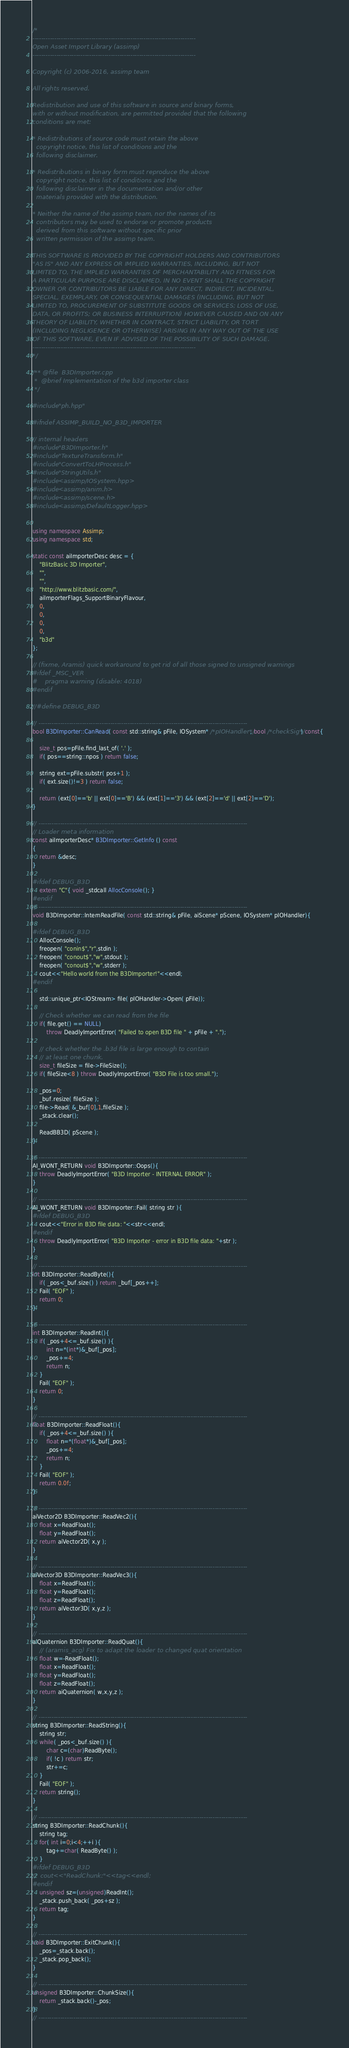Convert code to text. <code><loc_0><loc_0><loc_500><loc_500><_C++_>/*
---------------------------------------------------------------------------
Open Asset Import Library (assimp)
---------------------------------------------------------------------------

Copyright (c) 2006-2016, assimp team

All rights reserved.

Redistribution and use of this software in source and binary forms,
with or without modification, are permitted provided that the following
conditions are met:

* Redistributions of source code must retain the above
  copyright notice, this list of conditions and the
  following disclaimer.

* Redistributions in binary form must reproduce the above
  copyright notice, this list of conditions and the
  following disclaimer in the documentation and/or other
  materials provided with the distribution.

* Neither the name of the assimp team, nor the names of its
  contributors may be used to endorse or promote products
  derived from this software without specific prior
  written permission of the assimp team.

THIS SOFTWARE IS PROVIDED BY THE COPYRIGHT HOLDERS AND CONTRIBUTORS
"AS IS" AND ANY EXPRESS OR IMPLIED WARRANTIES, INCLUDING, BUT NOT
LIMITED TO, THE IMPLIED WARRANTIES OF MERCHANTABILITY AND FITNESS FOR
A PARTICULAR PURPOSE ARE DISCLAIMED. IN NO EVENT SHALL THE COPYRIGHT
OWNER OR CONTRIBUTORS BE LIABLE FOR ANY DIRECT, INDIRECT, INCIDENTAL,
SPECIAL, EXEMPLARY, OR CONSEQUENTIAL DAMAGES (INCLUDING, BUT NOT
LIMITED TO, PROCUREMENT OF SUBSTITUTE GOODS OR SERVICES; LOSS OF USE,
DATA, OR PROFITS; OR BUSINESS INTERRUPTION) HOWEVER CAUSED AND ON ANY
THEORY OF LIABILITY, WHETHER IN CONTRACT, STRICT LIABILITY, OR TORT
(INCLUDING NEGLIGENCE OR OTHERWISE) ARISING IN ANY WAY OUT OF THE USE
OF THIS SOFTWARE, EVEN IF ADVISED OF THE POSSIBILITY OF SUCH DAMAGE.
---------------------------------------------------------------------------
*/

/** @file  B3DImporter.cpp
 *  @brief Implementation of the b3d importer class
 */

#include "ph.hpp"

#ifndef ASSIMP_BUILD_NO_B3D_IMPORTER

// internal headers
#include "B3DImporter.h"
#include "TextureTransform.h"
#include "ConvertToLHProcess.h"
#include "StringUtils.h"
#include <assimp/IOSystem.hpp>
#include <assimp/anim.h>
#include <assimp/scene.h>
#include <assimp/DefaultLogger.hpp>


using namespace Assimp;
using namespace std;

static const aiImporterDesc desc = {
    "BlitzBasic 3D Importer",
    "",
    "",
    "http://www.blitzbasic.com/",
    aiImporterFlags_SupportBinaryFlavour,
    0,
    0,
    0,
    0,
    "b3d"
};

// (fixme, Aramis) quick workaround to get rid of all those signed to unsigned warnings
#ifdef _MSC_VER
#	pragma warning (disable: 4018)
#endif

//#define DEBUG_B3D

// ------------------------------------------------------------------------------------------------
bool B3DImporter::CanRead( const std::string& pFile, IOSystem* /*pIOHandler*/, bool /*checkSig*/) const{

    size_t pos=pFile.find_last_of( '.' );
    if( pos==string::npos ) return false;

    string ext=pFile.substr( pos+1 );
    if( ext.size()!=3 ) return false;

    return (ext[0]=='b' || ext[0]=='B') && (ext[1]=='3') && (ext[2]=='d' || ext[2]=='D');
}

// ------------------------------------------------------------------------------------------------
// Loader meta information
const aiImporterDesc* B3DImporter::GetInfo () const
{
    return &desc;
}

#ifdef DEBUG_B3D
    extern "C"{ void _stdcall AllocConsole(); }
#endif
// ------------------------------------------------------------------------------------------------
void B3DImporter::InternReadFile( const std::string& pFile, aiScene* pScene, IOSystem* pIOHandler){

#ifdef DEBUG_B3D
    AllocConsole();
    freopen( "conin$","r",stdin );
    freopen( "conout$","w",stdout );
    freopen( "conout$","w",stderr );
    cout<<"Hello world from the B3DImporter!"<<endl;
#endif

    std::unique_ptr<IOStream> file( pIOHandler->Open( pFile));

    // Check whether we can read from the file
    if( file.get() == NULL)
        throw DeadlyImportError( "Failed to open B3D file " + pFile + ".");

    // check whether the .b3d file is large enough to contain
    // at least one chunk.
    size_t fileSize = file->FileSize();
    if( fileSize<8 ) throw DeadlyImportError( "B3D File is too small.");

    _pos=0;
    _buf.resize( fileSize );
    file->Read( &_buf[0],1,fileSize );
    _stack.clear();

    ReadBB3D( pScene );
}

// ------------------------------------------------------------------------------------------------
AI_WONT_RETURN void B3DImporter::Oops(){
    throw DeadlyImportError( "B3D Importer - INTERNAL ERROR" );
}

// ------------------------------------------------------------------------------------------------
AI_WONT_RETURN void B3DImporter::Fail( string str ){
#ifdef DEBUG_B3D
    cout<<"Error in B3D file data: "<<str<<endl;
#endif
    throw DeadlyImportError( "B3D Importer - error in B3D file data: "+str );
}

// ------------------------------------------------------------------------------------------------
int B3DImporter::ReadByte(){
    if( _pos<_buf.size() ) return _buf[_pos++];
    Fail( "EOF" );
    return 0;
}

// ------------------------------------------------------------------------------------------------
int B3DImporter::ReadInt(){
    if( _pos+4<=_buf.size() ){
        int n=*(int*)&_buf[_pos];
        _pos+=4;
        return n;
    }
    Fail( "EOF" );
    return 0;
}

// ------------------------------------------------------------------------------------------------
float B3DImporter::ReadFloat(){
    if( _pos+4<=_buf.size() ){
        float n=*(float*)&_buf[_pos];
        _pos+=4;
        return n;
    }
    Fail( "EOF" );
    return 0.0f;
}

// ------------------------------------------------------------------------------------------------
aiVector2D B3DImporter::ReadVec2(){
    float x=ReadFloat();
    float y=ReadFloat();
    return aiVector2D( x,y );
}

// ------------------------------------------------------------------------------------------------
aiVector3D B3DImporter::ReadVec3(){
    float x=ReadFloat();
    float y=ReadFloat();
    float z=ReadFloat();
    return aiVector3D( x,y,z );
}

// ------------------------------------------------------------------------------------------------
aiQuaternion B3DImporter::ReadQuat(){
    // (aramis_acg) Fix to adapt the loader to changed quat orientation
    float w=-ReadFloat();
    float x=ReadFloat();
    float y=ReadFloat();
    float z=ReadFloat();
    return aiQuaternion( w,x,y,z );
}

// ------------------------------------------------------------------------------------------------
string B3DImporter::ReadString(){
    string str;
    while( _pos<_buf.size() ){
        char c=(char)ReadByte();
        if( !c ) return str;
        str+=c;
    }
    Fail( "EOF" );
    return string();
}

// ------------------------------------------------------------------------------------------------
string B3DImporter::ReadChunk(){
    string tag;
    for( int i=0;i<4;++i ){
        tag+=char( ReadByte() );
    }
#ifdef DEBUG_B3D
//	cout<<"ReadChunk:"<<tag<<endl;
#endif
    unsigned sz=(unsigned)ReadInt();
    _stack.push_back( _pos+sz );
    return tag;
}

// ------------------------------------------------------------------------------------------------
void B3DImporter::ExitChunk(){
    _pos=_stack.back();
    _stack.pop_back();
}

// ------------------------------------------------------------------------------------------------
unsigned B3DImporter::ChunkSize(){
    return _stack.back()-_pos;
}
// ------------------------------------------------------------------------------------------------
</code> 